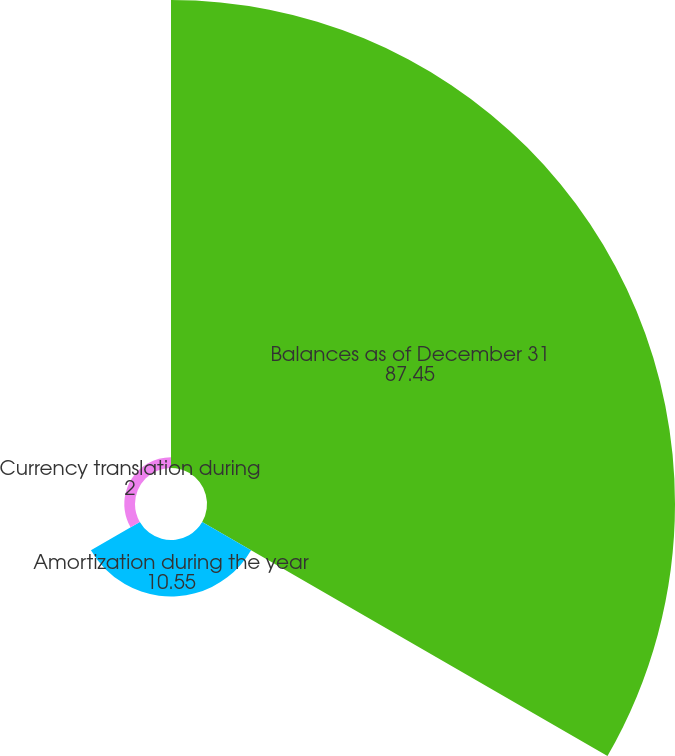Convert chart. <chart><loc_0><loc_0><loc_500><loc_500><pie_chart><fcel>Balances as of December 31<fcel>Amortization during the year<fcel>Currency translation during<nl><fcel>87.45%<fcel>10.55%<fcel>2.0%<nl></chart> 